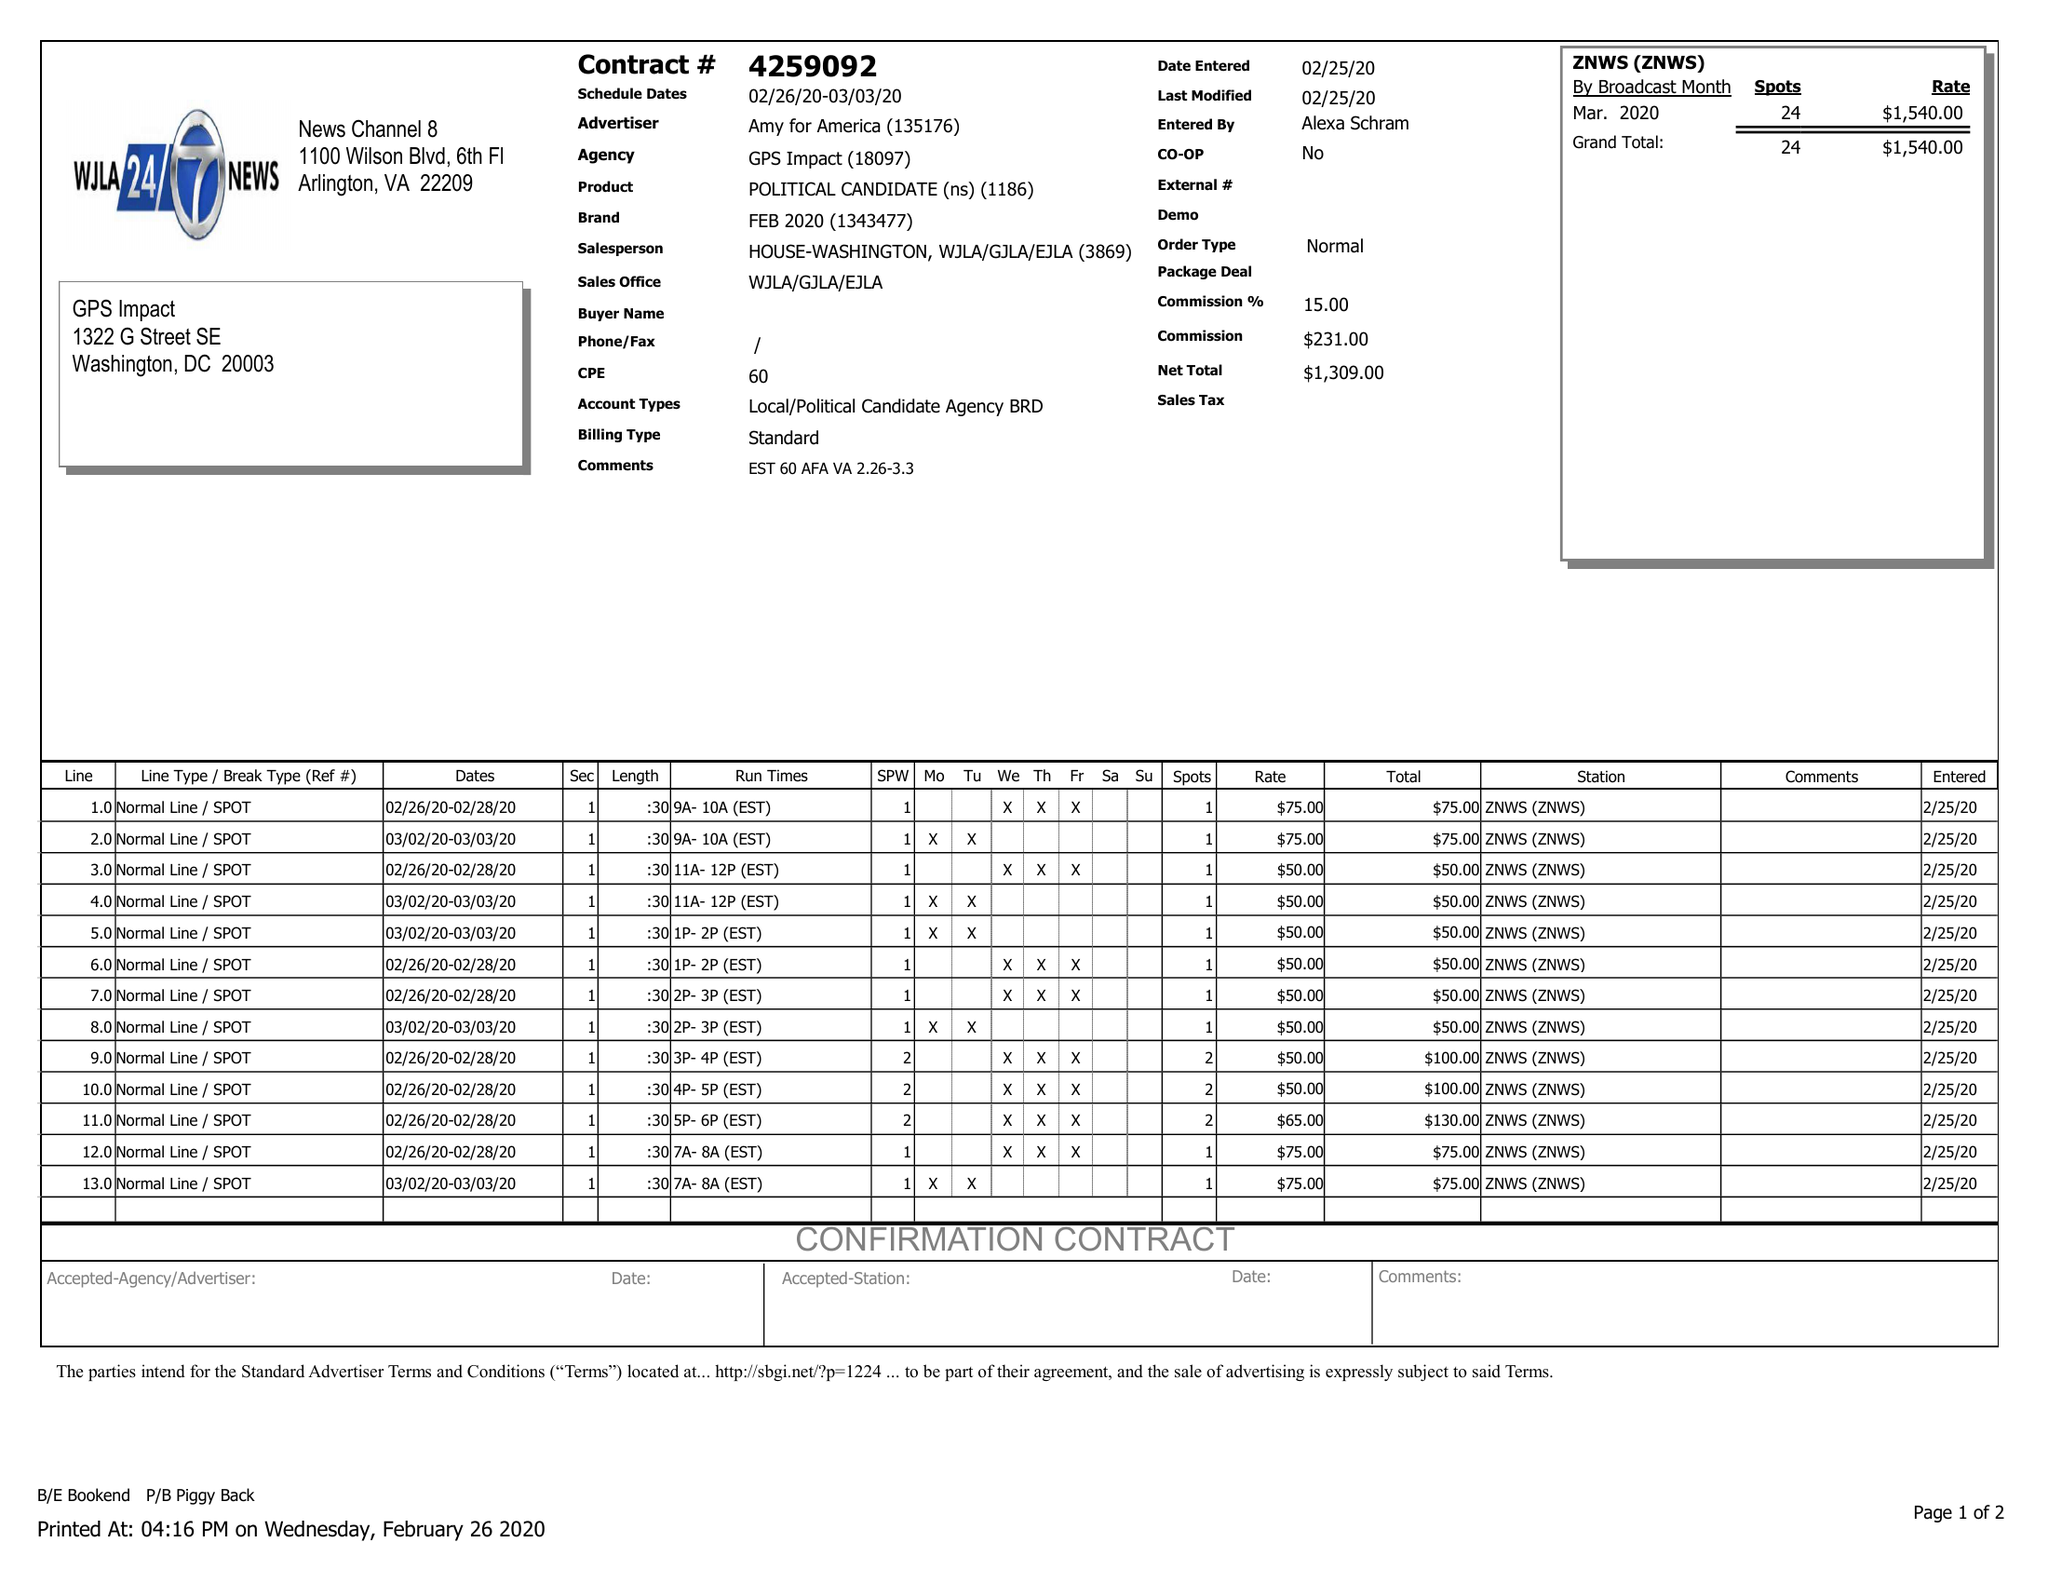What is the value for the contract_num?
Answer the question using a single word or phrase. 4259092 